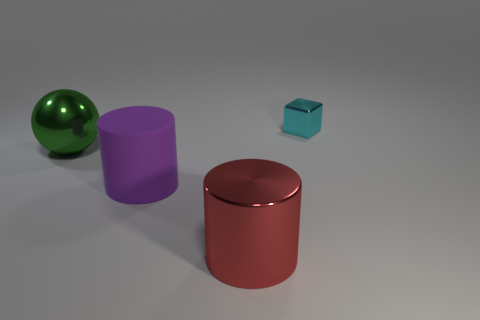Do the tiny thing and the metal object in front of the big green metallic sphere have the same color?
Your response must be concise. No. What size is the red metal thing that is the same shape as the rubber object?
Your answer should be compact. Large. What shape is the shiny object that is behind the large red metallic cylinder and on the left side of the cyan cube?
Make the answer very short. Sphere. Is the size of the cyan metal object the same as the metallic object to the left of the rubber cylinder?
Offer a very short reply. No. There is another metallic thing that is the same shape as the large purple object; what color is it?
Your answer should be very brief. Red. Does the metal thing that is behind the large green metallic thing have the same size as the thing left of the purple cylinder?
Your answer should be very brief. No. Is the large purple rubber thing the same shape as the large green metal object?
Offer a very short reply. No. What number of things are metal things that are left of the small cyan shiny cube or red cubes?
Provide a succinct answer. 2. Is there a small gray metallic object of the same shape as the large purple thing?
Offer a terse response. No. Are there the same number of metallic balls that are on the left side of the big green metal sphere and gray things?
Offer a terse response. Yes. 